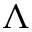Convert formula to latex. <formula><loc_0><loc_0><loc_500><loc_500>\Lambda</formula> 